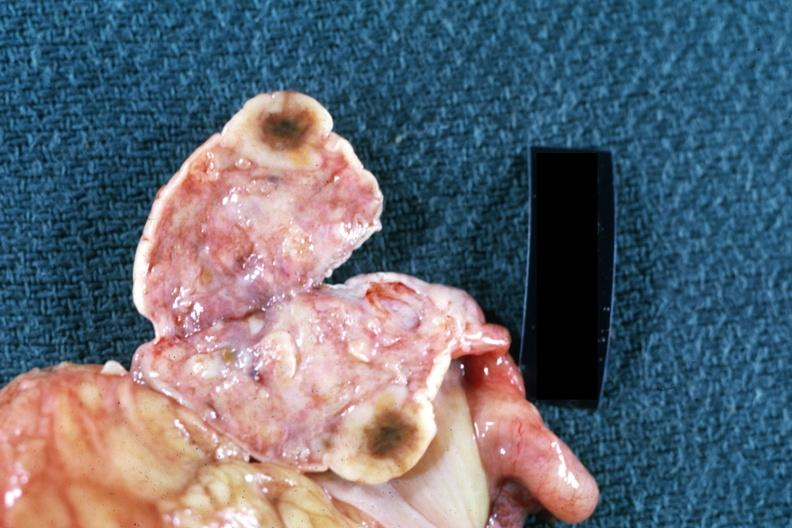does this image show close-up single lesion well shown breast primary?
Answer the question using a single word or phrase. Yes 